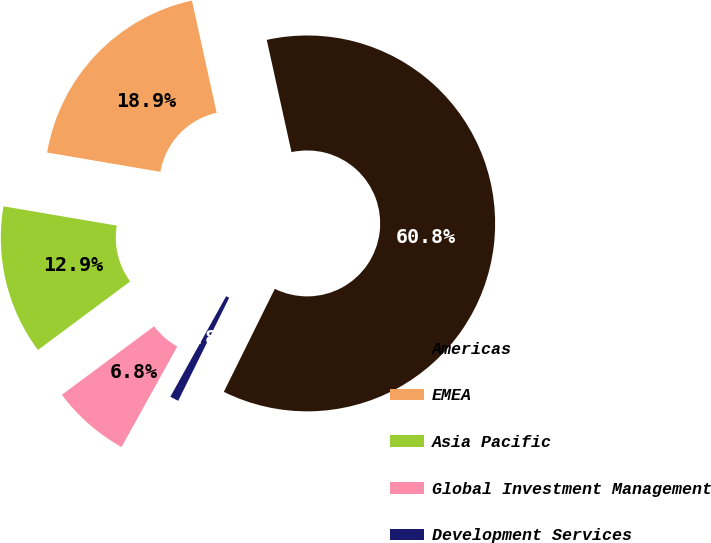<chart> <loc_0><loc_0><loc_500><loc_500><pie_chart><fcel>Americas<fcel>EMEA<fcel>Asia Pacific<fcel>Global Investment Management<fcel>Development Services<nl><fcel>60.76%<fcel>18.86%<fcel>12.86%<fcel>6.76%<fcel>0.75%<nl></chart> 